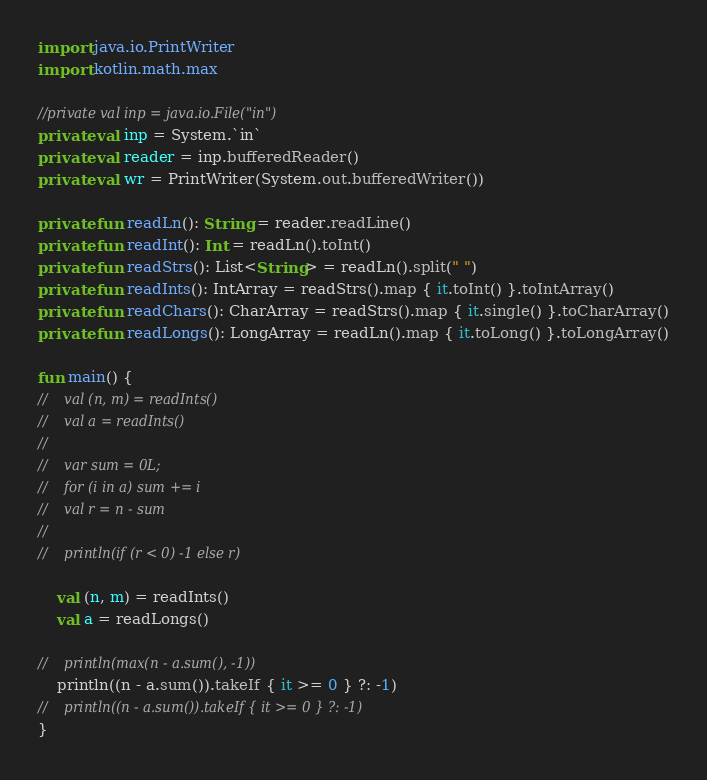<code> <loc_0><loc_0><loc_500><loc_500><_Kotlin_>import java.io.PrintWriter
import kotlin.math.max

//private val inp = java.io.File("in")
private val inp = System.`in`
private val reader = inp.bufferedReader()
private val wr = PrintWriter(System.out.bufferedWriter())

private fun readLn(): String = reader.readLine()
private fun readInt(): Int = readLn().toInt()
private fun readStrs(): List<String> = readLn().split(" ")
private fun readInts(): IntArray = readStrs().map { it.toInt() }.toIntArray()
private fun readChars(): CharArray = readStrs().map { it.single() }.toCharArray()
private fun readLongs(): LongArray = readLn().map { it.toLong() }.toLongArray()

fun main() {
//    val (n, m) = readInts()
//    val a = readInts()
//
//    var sum = 0L;
//    for (i in a) sum += i
//    val r = n - sum
//
//    println(if (r < 0) -1 else r)

    val (n, m) = readInts()
    val a = readLongs()

//    println(max(n - a.sum(), -1))
    println((n - a.sum()).takeIf { it >= 0 } ?: -1)
//    println((n - a.sum()).takeIf { it >= 0 } ?: -1)
}</code> 